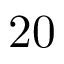<formula> <loc_0><loc_0><loc_500><loc_500>2 0</formula> 